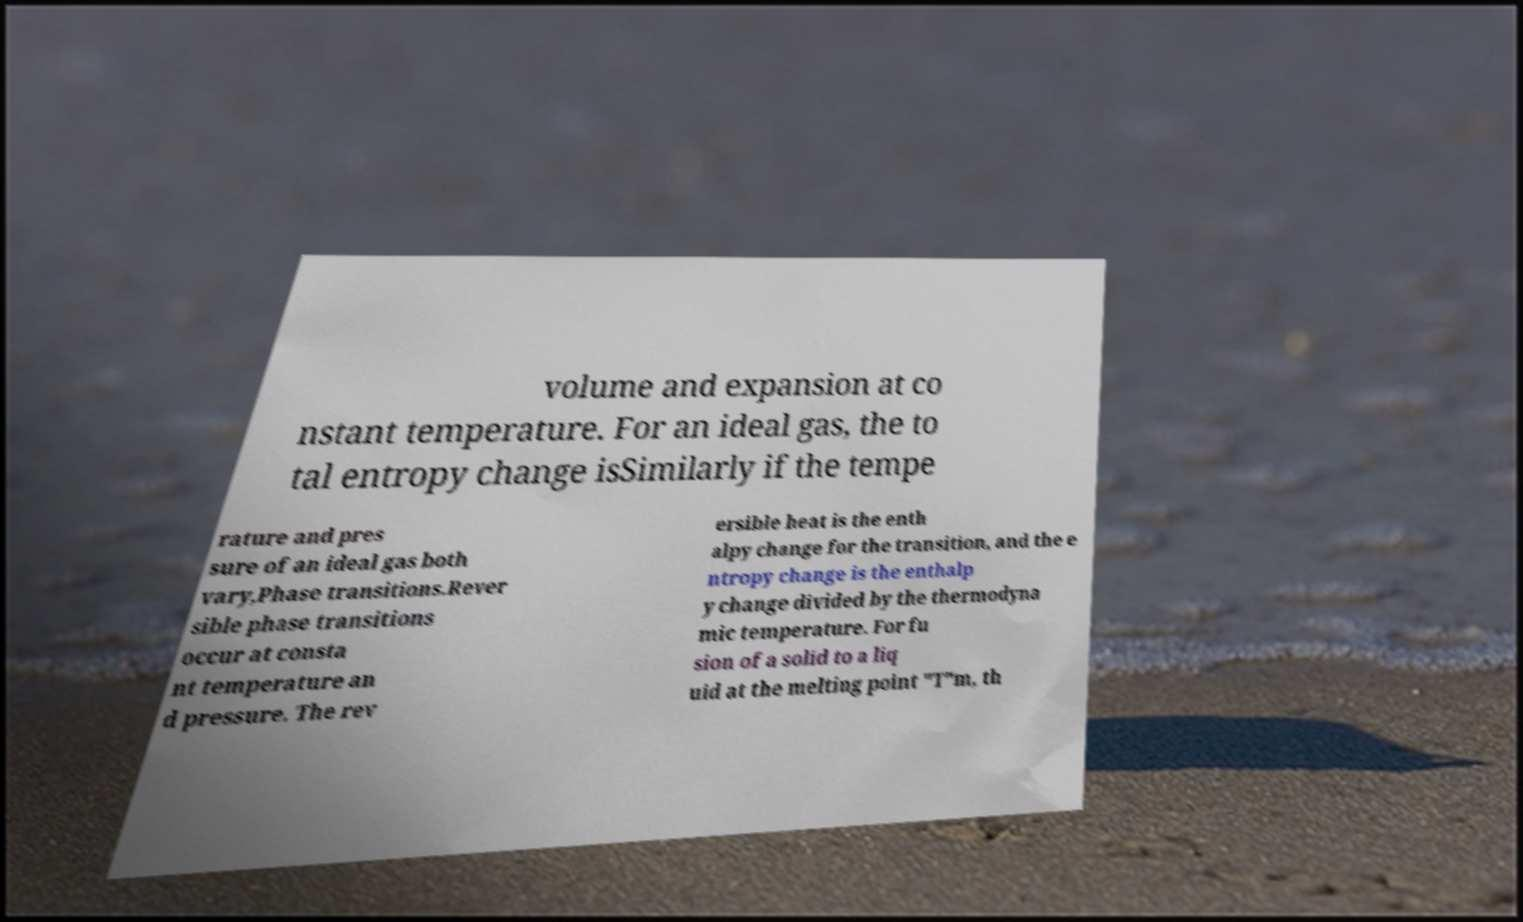Can you accurately transcribe the text from the provided image for me? volume and expansion at co nstant temperature. For an ideal gas, the to tal entropy change isSimilarly if the tempe rature and pres sure of an ideal gas both vary,Phase transitions.Rever sible phase transitions occur at consta nt temperature an d pressure. The rev ersible heat is the enth alpy change for the transition, and the e ntropy change is the enthalp y change divided by the thermodyna mic temperature. For fu sion of a solid to a liq uid at the melting point "T"m, th 